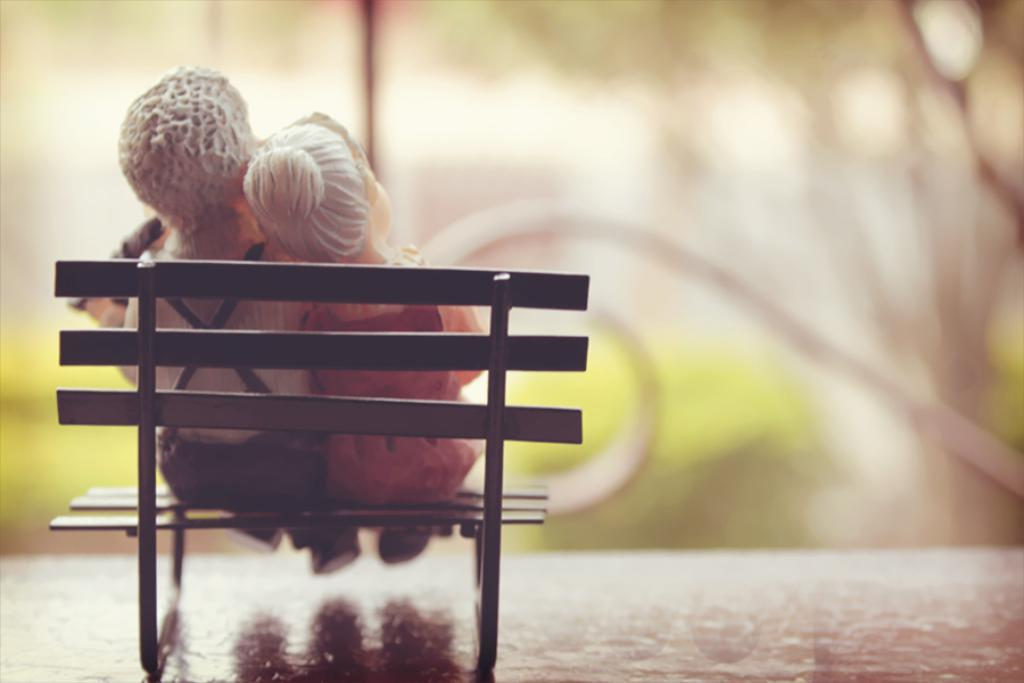How many dolls are in the image? There are two dolls in the image. Where are the dolls located? The dolls are on a bench. What is the bench resting on? The bench is over a table. What can be seen in the background of the image? There is railing visible in the background of the image. What type of fear does the doll on the left express in the image? There is no indication of fear or emotion expressed by the dolls in the image. 